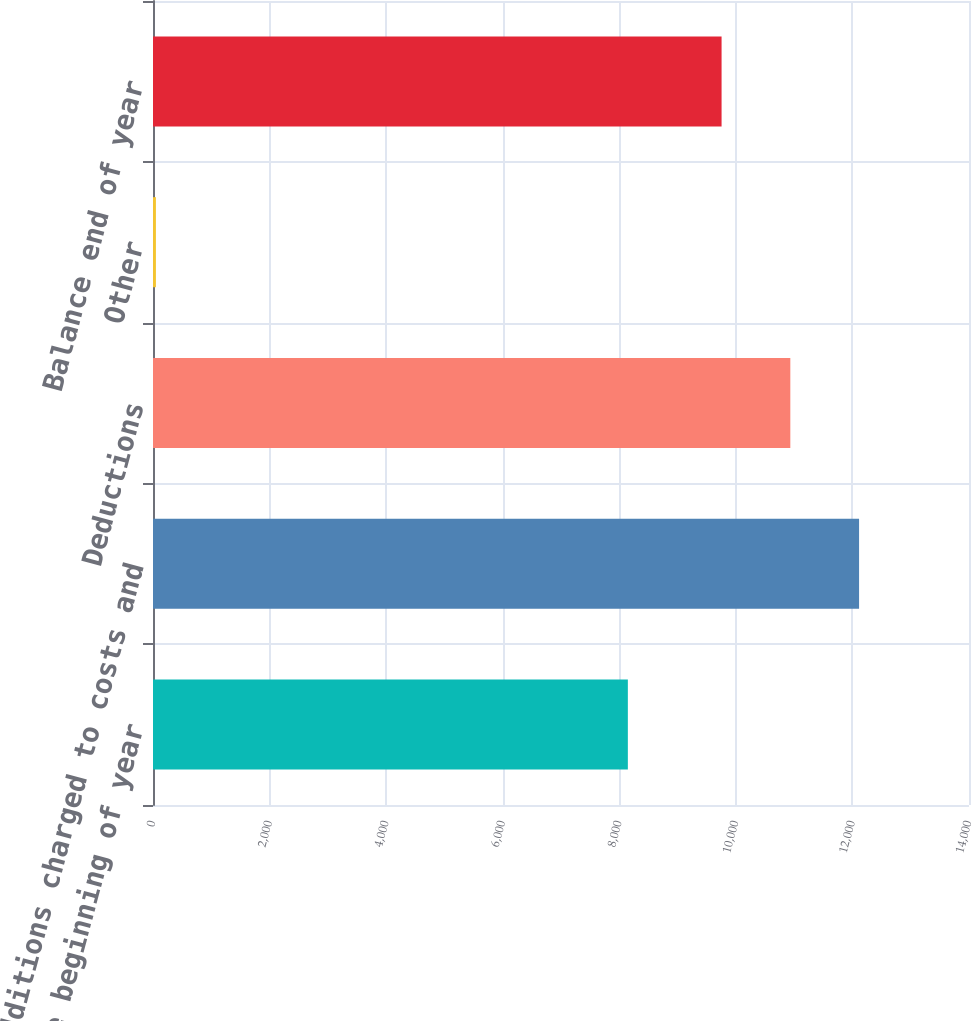Convert chart to OTSL. <chart><loc_0><loc_0><loc_500><loc_500><bar_chart><fcel>Balance beginning of year<fcel>Additions charged to costs and<fcel>Deductions<fcel>Other<fcel>Balance end of year<nl><fcel>8147<fcel>12114<fcel>10934.5<fcel>50<fcel>9755<nl></chart> 